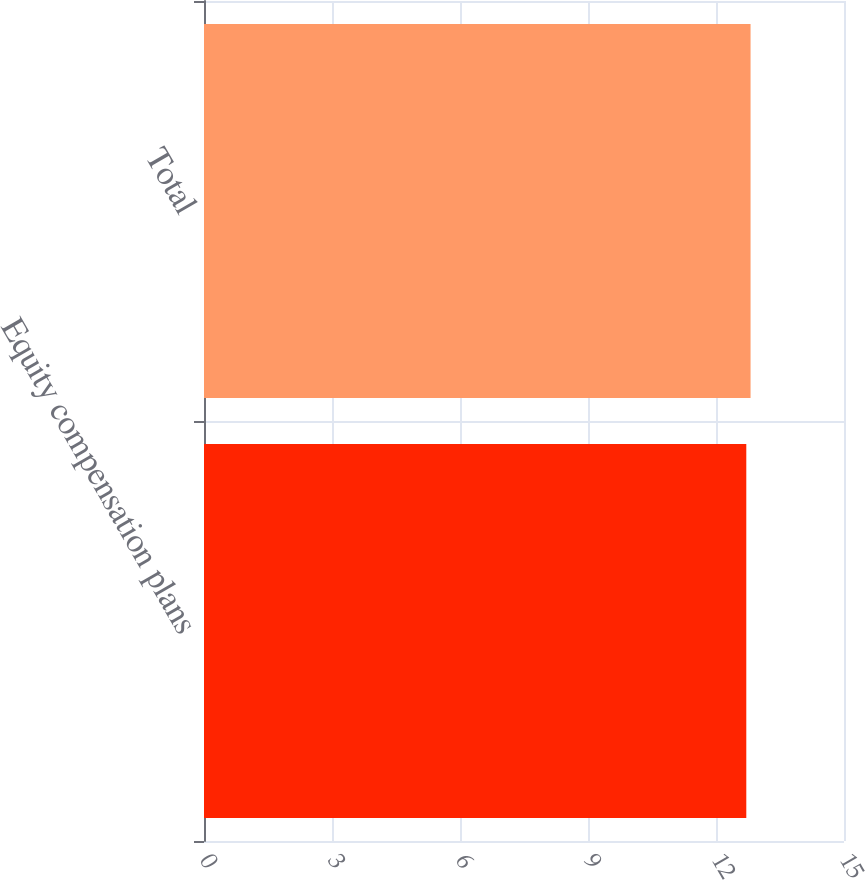Convert chart to OTSL. <chart><loc_0><loc_0><loc_500><loc_500><bar_chart><fcel>Equity compensation plans<fcel>Total<nl><fcel>12.71<fcel>12.81<nl></chart> 